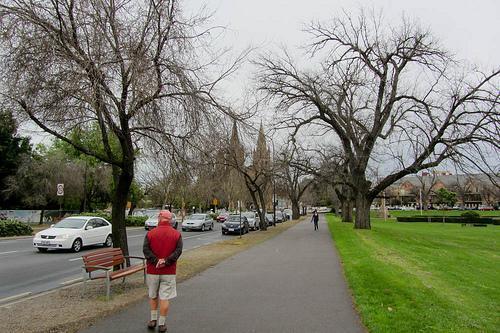How many people are there?
Give a very brief answer. 2. 